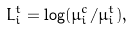<formula> <loc_0><loc_0><loc_500><loc_500>L _ { i } ^ { t } = \log ( \mu _ { i } ^ { c } / \mu _ { i } ^ { t } ) ,</formula> 